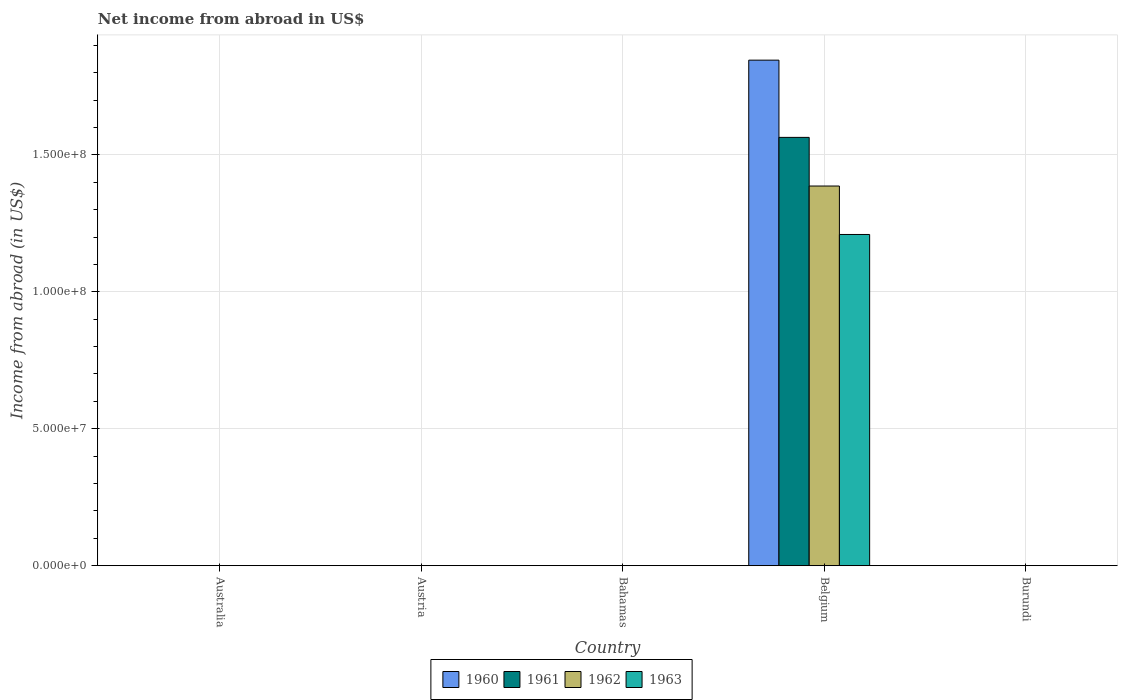Are the number of bars on each tick of the X-axis equal?
Make the answer very short. No. How many bars are there on the 1st tick from the left?
Offer a terse response. 0. How many bars are there on the 2nd tick from the right?
Make the answer very short. 4. What is the label of the 3rd group of bars from the left?
Keep it short and to the point. Bahamas. Across all countries, what is the maximum net income from abroad in 1963?
Give a very brief answer. 1.21e+08. In which country was the net income from abroad in 1961 maximum?
Your answer should be compact. Belgium. What is the total net income from abroad in 1960 in the graph?
Make the answer very short. 1.85e+08. What is the difference between the net income from abroad in 1960 in Belgium and the net income from abroad in 1962 in Burundi?
Keep it short and to the point. 1.85e+08. What is the average net income from abroad in 1961 per country?
Keep it short and to the point. 3.13e+07. What is the difference between the net income from abroad of/in 1963 and net income from abroad of/in 1962 in Belgium?
Your answer should be very brief. -1.77e+07. What is the difference between the highest and the lowest net income from abroad in 1962?
Offer a terse response. 1.39e+08. In how many countries, is the net income from abroad in 1961 greater than the average net income from abroad in 1961 taken over all countries?
Offer a very short reply. 1. Is it the case that in every country, the sum of the net income from abroad in 1962 and net income from abroad in 1961 is greater than the net income from abroad in 1960?
Keep it short and to the point. No. How many bars are there?
Give a very brief answer. 4. Are the values on the major ticks of Y-axis written in scientific E-notation?
Your answer should be compact. Yes. Does the graph contain any zero values?
Your response must be concise. Yes. Does the graph contain grids?
Keep it short and to the point. Yes. How are the legend labels stacked?
Provide a succinct answer. Horizontal. What is the title of the graph?
Your answer should be compact. Net income from abroad in US$. Does "1970" appear as one of the legend labels in the graph?
Keep it short and to the point. No. What is the label or title of the X-axis?
Keep it short and to the point. Country. What is the label or title of the Y-axis?
Give a very brief answer. Income from abroad (in US$). What is the Income from abroad (in US$) of 1960 in Australia?
Offer a very short reply. 0. What is the Income from abroad (in US$) in 1961 in Austria?
Ensure brevity in your answer.  0. What is the Income from abroad (in US$) of 1963 in Bahamas?
Make the answer very short. 0. What is the Income from abroad (in US$) in 1960 in Belgium?
Provide a short and direct response. 1.85e+08. What is the Income from abroad (in US$) of 1961 in Belgium?
Provide a short and direct response. 1.56e+08. What is the Income from abroad (in US$) of 1962 in Belgium?
Provide a short and direct response. 1.39e+08. What is the Income from abroad (in US$) in 1963 in Belgium?
Provide a short and direct response. 1.21e+08. What is the Income from abroad (in US$) in 1960 in Burundi?
Offer a terse response. 0. What is the Income from abroad (in US$) of 1961 in Burundi?
Provide a succinct answer. 0. Across all countries, what is the maximum Income from abroad (in US$) in 1960?
Keep it short and to the point. 1.85e+08. Across all countries, what is the maximum Income from abroad (in US$) in 1961?
Provide a succinct answer. 1.56e+08. Across all countries, what is the maximum Income from abroad (in US$) of 1962?
Keep it short and to the point. 1.39e+08. Across all countries, what is the maximum Income from abroad (in US$) in 1963?
Offer a terse response. 1.21e+08. Across all countries, what is the minimum Income from abroad (in US$) in 1960?
Make the answer very short. 0. Across all countries, what is the minimum Income from abroad (in US$) of 1961?
Your answer should be compact. 0. Across all countries, what is the minimum Income from abroad (in US$) in 1962?
Provide a short and direct response. 0. What is the total Income from abroad (in US$) of 1960 in the graph?
Provide a short and direct response. 1.85e+08. What is the total Income from abroad (in US$) of 1961 in the graph?
Offer a very short reply. 1.56e+08. What is the total Income from abroad (in US$) of 1962 in the graph?
Keep it short and to the point. 1.39e+08. What is the total Income from abroad (in US$) in 1963 in the graph?
Offer a very short reply. 1.21e+08. What is the average Income from abroad (in US$) in 1960 per country?
Keep it short and to the point. 3.69e+07. What is the average Income from abroad (in US$) of 1961 per country?
Your answer should be compact. 3.13e+07. What is the average Income from abroad (in US$) in 1962 per country?
Keep it short and to the point. 2.77e+07. What is the average Income from abroad (in US$) in 1963 per country?
Your response must be concise. 2.42e+07. What is the difference between the Income from abroad (in US$) of 1960 and Income from abroad (in US$) of 1961 in Belgium?
Ensure brevity in your answer.  2.82e+07. What is the difference between the Income from abroad (in US$) of 1960 and Income from abroad (in US$) of 1962 in Belgium?
Your answer should be very brief. 4.60e+07. What is the difference between the Income from abroad (in US$) of 1960 and Income from abroad (in US$) of 1963 in Belgium?
Your response must be concise. 6.37e+07. What is the difference between the Income from abroad (in US$) in 1961 and Income from abroad (in US$) in 1962 in Belgium?
Your answer should be compact. 1.78e+07. What is the difference between the Income from abroad (in US$) in 1961 and Income from abroad (in US$) in 1963 in Belgium?
Ensure brevity in your answer.  3.55e+07. What is the difference between the Income from abroad (in US$) of 1962 and Income from abroad (in US$) of 1963 in Belgium?
Provide a succinct answer. 1.77e+07. What is the difference between the highest and the lowest Income from abroad (in US$) in 1960?
Keep it short and to the point. 1.85e+08. What is the difference between the highest and the lowest Income from abroad (in US$) in 1961?
Offer a very short reply. 1.56e+08. What is the difference between the highest and the lowest Income from abroad (in US$) in 1962?
Ensure brevity in your answer.  1.39e+08. What is the difference between the highest and the lowest Income from abroad (in US$) of 1963?
Your response must be concise. 1.21e+08. 